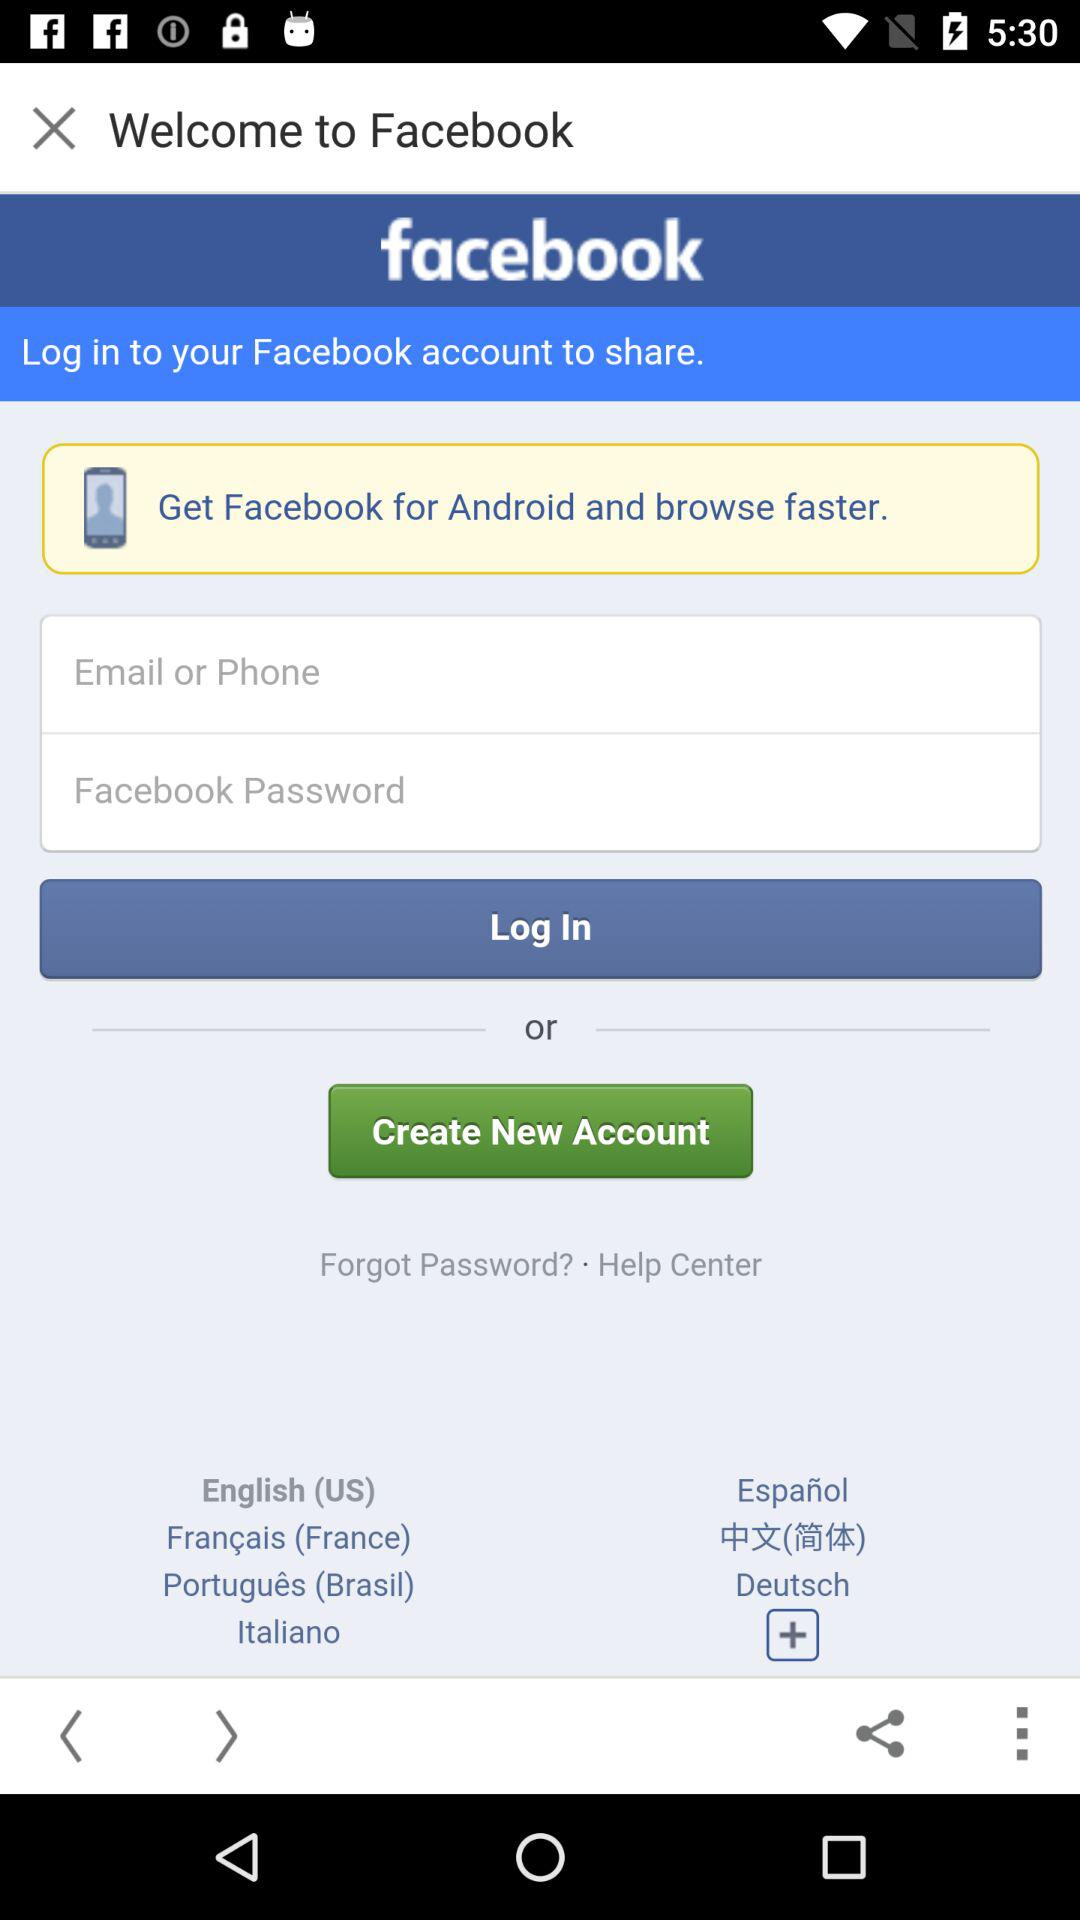What is the name of the application? The name of the application is "facebook". 